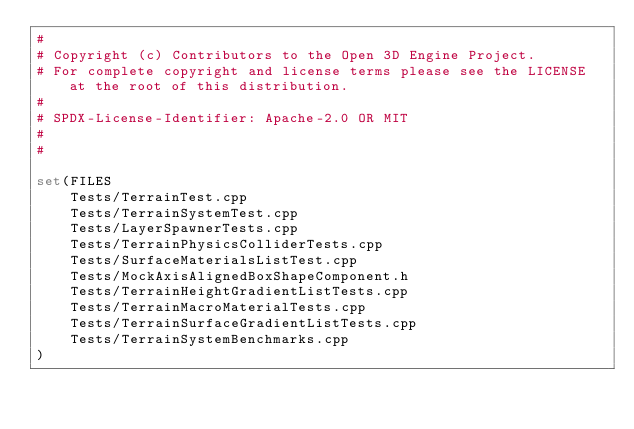<code> <loc_0><loc_0><loc_500><loc_500><_CMake_>#
# Copyright (c) Contributors to the Open 3D Engine Project.
# For complete copyright and license terms please see the LICENSE at the root of this distribution.
#
# SPDX-License-Identifier: Apache-2.0 OR MIT
#
#

set(FILES
    Tests/TerrainTest.cpp
    Tests/TerrainSystemTest.cpp
    Tests/LayerSpawnerTests.cpp
    Tests/TerrainPhysicsColliderTests.cpp
    Tests/SurfaceMaterialsListTest.cpp
    Tests/MockAxisAlignedBoxShapeComponent.h
    Tests/TerrainHeightGradientListTests.cpp
    Tests/TerrainMacroMaterialTests.cpp
    Tests/TerrainSurfaceGradientListTests.cpp
    Tests/TerrainSystemBenchmarks.cpp
)
</code> 